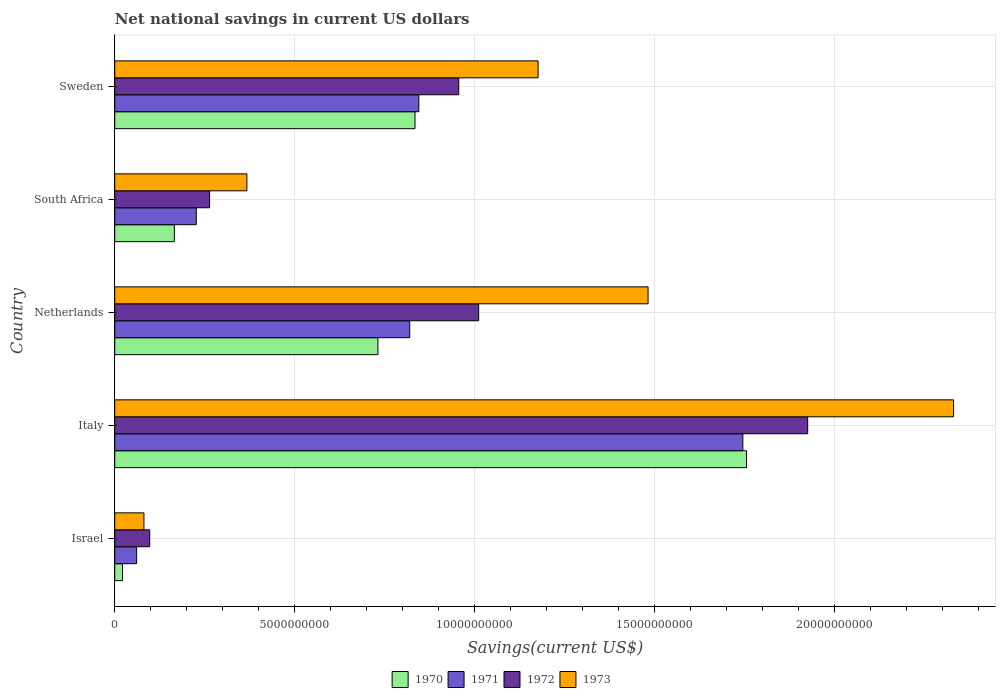What is the label of the 2nd group of bars from the top?
Your answer should be compact. South Africa. What is the net national savings in 1971 in Sweden?
Provide a succinct answer. 8.45e+09. Across all countries, what is the maximum net national savings in 1973?
Provide a succinct answer. 2.33e+1. Across all countries, what is the minimum net national savings in 1973?
Give a very brief answer. 8.11e+08. In which country was the net national savings in 1971 maximum?
Your answer should be very brief. Italy. What is the total net national savings in 1972 in the graph?
Make the answer very short. 4.25e+1. What is the difference between the net national savings in 1971 in Israel and that in Italy?
Provide a succinct answer. -1.68e+1. What is the difference between the net national savings in 1970 in Israel and the net national savings in 1971 in South Africa?
Your response must be concise. -2.05e+09. What is the average net national savings in 1970 per country?
Provide a short and direct response. 7.02e+09. What is the difference between the net national savings in 1970 and net national savings in 1973 in Italy?
Give a very brief answer. -5.75e+09. In how many countries, is the net national savings in 1971 greater than 15000000000 US$?
Your answer should be very brief. 1. What is the ratio of the net national savings in 1972 in South Africa to that in Sweden?
Give a very brief answer. 0.28. Is the net national savings in 1972 in Italy less than that in South Africa?
Provide a short and direct response. No. What is the difference between the highest and the second highest net national savings in 1970?
Your answer should be compact. 9.21e+09. What is the difference between the highest and the lowest net national savings in 1970?
Offer a very short reply. 1.73e+1. What does the 4th bar from the bottom in Israel represents?
Your response must be concise. 1973. How many countries are there in the graph?
Provide a short and direct response. 5. Are the values on the major ticks of X-axis written in scientific E-notation?
Your answer should be compact. No. Does the graph contain any zero values?
Ensure brevity in your answer.  No. Does the graph contain grids?
Ensure brevity in your answer.  Yes. How many legend labels are there?
Your answer should be compact. 4. What is the title of the graph?
Make the answer very short. Net national savings in current US dollars. Does "1963" appear as one of the legend labels in the graph?
Keep it short and to the point. No. What is the label or title of the X-axis?
Provide a succinct answer. Savings(current US$). What is the label or title of the Y-axis?
Make the answer very short. Country. What is the Savings(current US$) in 1970 in Israel?
Make the answer very short. 2.15e+08. What is the Savings(current US$) in 1971 in Israel?
Provide a short and direct response. 6.09e+08. What is the Savings(current US$) in 1972 in Israel?
Ensure brevity in your answer.  9.71e+08. What is the Savings(current US$) in 1973 in Israel?
Offer a very short reply. 8.11e+08. What is the Savings(current US$) in 1970 in Italy?
Provide a succinct answer. 1.76e+1. What is the Savings(current US$) of 1971 in Italy?
Your answer should be very brief. 1.75e+1. What is the Savings(current US$) in 1972 in Italy?
Give a very brief answer. 1.93e+1. What is the Savings(current US$) of 1973 in Italy?
Provide a short and direct response. 2.33e+1. What is the Savings(current US$) of 1970 in Netherlands?
Offer a very short reply. 7.31e+09. What is the Savings(current US$) of 1971 in Netherlands?
Your answer should be very brief. 8.20e+09. What is the Savings(current US$) of 1972 in Netherlands?
Provide a short and direct response. 1.01e+1. What is the Savings(current US$) of 1973 in Netherlands?
Your answer should be compact. 1.48e+1. What is the Savings(current US$) of 1970 in South Africa?
Provide a short and direct response. 1.66e+09. What is the Savings(current US$) of 1971 in South Africa?
Keep it short and to the point. 2.27e+09. What is the Savings(current US$) in 1972 in South Africa?
Offer a terse response. 2.64e+09. What is the Savings(current US$) of 1973 in South Africa?
Ensure brevity in your answer.  3.67e+09. What is the Savings(current US$) of 1970 in Sweden?
Your response must be concise. 8.34e+09. What is the Savings(current US$) of 1971 in Sweden?
Your answer should be very brief. 8.45e+09. What is the Savings(current US$) of 1972 in Sweden?
Make the answer very short. 9.56e+09. What is the Savings(current US$) in 1973 in Sweden?
Offer a terse response. 1.18e+1. Across all countries, what is the maximum Savings(current US$) of 1970?
Give a very brief answer. 1.76e+1. Across all countries, what is the maximum Savings(current US$) of 1971?
Ensure brevity in your answer.  1.75e+1. Across all countries, what is the maximum Savings(current US$) in 1972?
Give a very brief answer. 1.93e+1. Across all countries, what is the maximum Savings(current US$) of 1973?
Your answer should be very brief. 2.33e+1. Across all countries, what is the minimum Savings(current US$) of 1970?
Keep it short and to the point. 2.15e+08. Across all countries, what is the minimum Savings(current US$) in 1971?
Your answer should be compact. 6.09e+08. Across all countries, what is the minimum Savings(current US$) in 1972?
Keep it short and to the point. 9.71e+08. Across all countries, what is the minimum Savings(current US$) of 1973?
Offer a very short reply. 8.11e+08. What is the total Savings(current US$) of 1970 in the graph?
Ensure brevity in your answer.  3.51e+1. What is the total Savings(current US$) of 1971 in the graph?
Offer a very short reply. 3.70e+1. What is the total Savings(current US$) of 1972 in the graph?
Offer a very short reply. 4.25e+1. What is the total Savings(current US$) in 1973 in the graph?
Offer a terse response. 5.44e+1. What is the difference between the Savings(current US$) of 1970 in Israel and that in Italy?
Offer a very short reply. -1.73e+1. What is the difference between the Savings(current US$) in 1971 in Israel and that in Italy?
Offer a very short reply. -1.68e+1. What is the difference between the Savings(current US$) in 1972 in Israel and that in Italy?
Your answer should be compact. -1.83e+1. What is the difference between the Savings(current US$) in 1973 in Israel and that in Italy?
Keep it short and to the point. -2.25e+1. What is the difference between the Savings(current US$) of 1970 in Israel and that in Netherlands?
Your answer should be compact. -7.10e+09. What is the difference between the Savings(current US$) of 1971 in Israel and that in Netherlands?
Your response must be concise. -7.59e+09. What is the difference between the Savings(current US$) of 1972 in Israel and that in Netherlands?
Make the answer very short. -9.14e+09. What is the difference between the Savings(current US$) of 1973 in Israel and that in Netherlands?
Your answer should be very brief. -1.40e+1. What is the difference between the Savings(current US$) of 1970 in Israel and that in South Africa?
Your answer should be compact. -1.44e+09. What is the difference between the Savings(current US$) of 1971 in Israel and that in South Africa?
Offer a terse response. -1.66e+09. What is the difference between the Savings(current US$) of 1972 in Israel and that in South Africa?
Your response must be concise. -1.66e+09. What is the difference between the Savings(current US$) in 1973 in Israel and that in South Africa?
Ensure brevity in your answer.  -2.86e+09. What is the difference between the Savings(current US$) of 1970 in Israel and that in Sweden?
Ensure brevity in your answer.  -8.13e+09. What is the difference between the Savings(current US$) of 1971 in Israel and that in Sweden?
Provide a short and direct response. -7.84e+09. What is the difference between the Savings(current US$) in 1972 in Israel and that in Sweden?
Offer a very short reply. -8.59e+09. What is the difference between the Savings(current US$) of 1973 in Israel and that in Sweden?
Ensure brevity in your answer.  -1.10e+1. What is the difference between the Savings(current US$) of 1970 in Italy and that in Netherlands?
Give a very brief answer. 1.02e+1. What is the difference between the Savings(current US$) in 1971 in Italy and that in Netherlands?
Offer a terse response. 9.26e+09. What is the difference between the Savings(current US$) in 1972 in Italy and that in Netherlands?
Keep it short and to the point. 9.14e+09. What is the difference between the Savings(current US$) of 1973 in Italy and that in Netherlands?
Your response must be concise. 8.49e+09. What is the difference between the Savings(current US$) in 1970 in Italy and that in South Africa?
Your answer should be very brief. 1.59e+1. What is the difference between the Savings(current US$) in 1971 in Italy and that in South Africa?
Keep it short and to the point. 1.52e+1. What is the difference between the Savings(current US$) of 1972 in Italy and that in South Africa?
Provide a short and direct response. 1.66e+1. What is the difference between the Savings(current US$) of 1973 in Italy and that in South Africa?
Provide a short and direct response. 1.96e+1. What is the difference between the Savings(current US$) in 1970 in Italy and that in Sweden?
Provide a succinct answer. 9.21e+09. What is the difference between the Savings(current US$) in 1971 in Italy and that in Sweden?
Make the answer very short. 9.00e+09. What is the difference between the Savings(current US$) in 1972 in Italy and that in Sweden?
Offer a very short reply. 9.70e+09. What is the difference between the Savings(current US$) of 1973 in Italy and that in Sweden?
Provide a short and direct response. 1.15e+1. What is the difference between the Savings(current US$) in 1970 in Netherlands and that in South Africa?
Your response must be concise. 5.66e+09. What is the difference between the Savings(current US$) in 1971 in Netherlands and that in South Africa?
Provide a short and direct response. 5.93e+09. What is the difference between the Savings(current US$) of 1972 in Netherlands and that in South Africa?
Your answer should be very brief. 7.48e+09. What is the difference between the Savings(current US$) of 1973 in Netherlands and that in South Africa?
Your response must be concise. 1.11e+1. What is the difference between the Savings(current US$) of 1970 in Netherlands and that in Sweden?
Make the answer very short. -1.03e+09. What is the difference between the Savings(current US$) in 1971 in Netherlands and that in Sweden?
Make the answer very short. -2.53e+08. What is the difference between the Savings(current US$) of 1972 in Netherlands and that in Sweden?
Your answer should be very brief. 5.54e+08. What is the difference between the Savings(current US$) in 1973 in Netherlands and that in Sweden?
Offer a terse response. 3.06e+09. What is the difference between the Savings(current US$) of 1970 in South Africa and that in Sweden?
Keep it short and to the point. -6.69e+09. What is the difference between the Savings(current US$) of 1971 in South Africa and that in Sweden?
Make the answer very short. -6.18e+09. What is the difference between the Savings(current US$) in 1972 in South Africa and that in Sweden?
Provide a short and direct response. -6.92e+09. What is the difference between the Savings(current US$) of 1973 in South Africa and that in Sweden?
Offer a very short reply. -8.09e+09. What is the difference between the Savings(current US$) of 1970 in Israel and the Savings(current US$) of 1971 in Italy?
Make the answer very short. -1.72e+1. What is the difference between the Savings(current US$) of 1970 in Israel and the Savings(current US$) of 1972 in Italy?
Your answer should be compact. -1.90e+1. What is the difference between the Savings(current US$) of 1970 in Israel and the Savings(current US$) of 1973 in Italy?
Offer a terse response. -2.31e+1. What is the difference between the Savings(current US$) of 1971 in Israel and the Savings(current US$) of 1972 in Italy?
Provide a succinct answer. -1.86e+1. What is the difference between the Savings(current US$) of 1971 in Israel and the Savings(current US$) of 1973 in Italy?
Ensure brevity in your answer.  -2.27e+1. What is the difference between the Savings(current US$) of 1972 in Israel and the Savings(current US$) of 1973 in Italy?
Provide a short and direct response. -2.23e+1. What is the difference between the Savings(current US$) in 1970 in Israel and the Savings(current US$) in 1971 in Netherlands?
Give a very brief answer. -7.98e+09. What is the difference between the Savings(current US$) of 1970 in Israel and the Savings(current US$) of 1972 in Netherlands?
Ensure brevity in your answer.  -9.90e+09. What is the difference between the Savings(current US$) in 1970 in Israel and the Savings(current US$) in 1973 in Netherlands?
Your response must be concise. -1.46e+1. What is the difference between the Savings(current US$) of 1971 in Israel and the Savings(current US$) of 1972 in Netherlands?
Provide a short and direct response. -9.50e+09. What is the difference between the Savings(current US$) in 1971 in Israel and the Savings(current US$) in 1973 in Netherlands?
Offer a terse response. -1.42e+1. What is the difference between the Savings(current US$) in 1972 in Israel and the Savings(current US$) in 1973 in Netherlands?
Offer a terse response. -1.38e+1. What is the difference between the Savings(current US$) in 1970 in Israel and the Savings(current US$) in 1971 in South Africa?
Ensure brevity in your answer.  -2.05e+09. What is the difference between the Savings(current US$) of 1970 in Israel and the Savings(current US$) of 1972 in South Africa?
Offer a terse response. -2.42e+09. What is the difference between the Savings(current US$) in 1970 in Israel and the Savings(current US$) in 1973 in South Africa?
Keep it short and to the point. -3.46e+09. What is the difference between the Savings(current US$) in 1971 in Israel and the Savings(current US$) in 1972 in South Africa?
Make the answer very short. -2.03e+09. What is the difference between the Savings(current US$) in 1971 in Israel and the Savings(current US$) in 1973 in South Africa?
Offer a very short reply. -3.06e+09. What is the difference between the Savings(current US$) of 1972 in Israel and the Savings(current US$) of 1973 in South Africa?
Ensure brevity in your answer.  -2.70e+09. What is the difference between the Savings(current US$) of 1970 in Israel and the Savings(current US$) of 1971 in Sweden?
Your answer should be compact. -8.23e+09. What is the difference between the Savings(current US$) of 1970 in Israel and the Savings(current US$) of 1972 in Sweden?
Offer a very short reply. -9.34e+09. What is the difference between the Savings(current US$) of 1970 in Israel and the Savings(current US$) of 1973 in Sweden?
Give a very brief answer. -1.15e+1. What is the difference between the Savings(current US$) of 1971 in Israel and the Savings(current US$) of 1972 in Sweden?
Ensure brevity in your answer.  -8.95e+09. What is the difference between the Savings(current US$) in 1971 in Israel and the Savings(current US$) in 1973 in Sweden?
Provide a short and direct response. -1.12e+1. What is the difference between the Savings(current US$) in 1972 in Israel and the Savings(current US$) in 1973 in Sweden?
Provide a short and direct response. -1.08e+1. What is the difference between the Savings(current US$) of 1970 in Italy and the Savings(current US$) of 1971 in Netherlands?
Ensure brevity in your answer.  9.36e+09. What is the difference between the Savings(current US$) in 1970 in Italy and the Savings(current US$) in 1972 in Netherlands?
Your answer should be compact. 7.44e+09. What is the difference between the Savings(current US$) in 1970 in Italy and the Savings(current US$) in 1973 in Netherlands?
Provide a short and direct response. 2.74e+09. What is the difference between the Savings(current US$) of 1971 in Italy and the Savings(current US$) of 1972 in Netherlands?
Provide a succinct answer. 7.34e+09. What is the difference between the Savings(current US$) in 1971 in Italy and the Savings(current US$) in 1973 in Netherlands?
Your answer should be very brief. 2.63e+09. What is the difference between the Savings(current US$) in 1972 in Italy and the Savings(current US$) in 1973 in Netherlands?
Offer a very short reply. 4.44e+09. What is the difference between the Savings(current US$) in 1970 in Italy and the Savings(current US$) in 1971 in South Africa?
Offer a very short reply. 1.53e+1. What is the difference between the Savings(current US$) in 1970 in Italy and the Savings(current US$) in 1972 in South Africa?
Your answer should be very brief. 1.49e+1. What is the difference between the Savings(current US$) of 1970 in Italy and the Savings(current US$) of 1973 in South Africa?
Keep it short and to the point. 1.39e+1. What is the difference between the Savings(current US$) of 1971 in Italy and the Savings(current US$) of 1972 in South Africa?
Offer a very short reply. 1.48e+1. What is the difference between the Savings(current US$) in 1971 in Italy and the Savings(current US$) in 1973 in South Africa?
Your response must be concise. 1.38e+1. What is the difference between the Savings(current US$) in 1972 in Italy and the Savings(current US$) in 1973 in South Africa?
Your answer should be very brief. 1.56e+1. What is the difference between the Savings(current US$) in 1970 in Italy and the Savings(current US$) in 1971 in Sweden?
Keep it short and to the point. 9.11e+09. What is the difference between the Savings(current US$) of 1970 in Italy and the Savings(current US$) of 1972 in Sweden?
Provide a succinct answer. 8.00e+09. What is the difference between the Savings(current US$) of 1970 in Italy and the Savings(current US$) of 1973 in Sweden?
Your answer should be very brief. 5.79e+09. What is the difference between the Savings(current US$) in 1971 in Italy and the Savings(current US$) in 1972 in Sweden?
Your response must be concise. 7.89e+09. What is the difference between the Savings(current US$) in 1971 in Italy and the Savings(current US$) in 1973 in Sweden?
Your answer should be compact. 5.69e+09. What is the difference between the Savings(current US$) of 1972 in Italy and the Savings(current US$) of 1973 in Sweden?
Give a very brief answer. 7.49e+09. What is the difference between the Savings(current US$) in 1970 in Netherlands and the Savings(current US$) in 1971 in South Africa?
Give a very brief answer. 5.05e+09. What is the difference between the Savings(current US$) of 1970 in Netherlands and the Savings(current US$) of 1972 in South Africa?
Give a very brief answer. 4.68e+09. What is the difference between the Savings(current US$) of 1970 in Netherlands and the Savings(current US$) of 1973 in South Africa?
Ensure brevity in your answer.  3.64e+09. What is the difference between the Savings(current US$) in 1971 in Netherlands and the Savings(current US$) in 1972 in South Africa?
Your answer should be compact. 5.56e+09. What is the difference between the Savings(current US$) in 1971 in Netherlands and the Savings(current US$) in 1973 in South Africa?
Keep it short and to the point. 4.52e+09. What is the difference between the Savings(current US$) of 1972 in Netherlands and the Savings(current US$) of 1973 in South Africa?
Your response must be concise. 6.44e+09. What is the difference between the Savings(current US$) in 1970 in Netherlands and the Savings(current US$) in 1971 in Sweden?
Your response must be concise. -1.14e+09. What is the difference between the Savings(current US$) of 1970 in Netherlands and the Savings(current US$) of 1972 in Sweden?
Give a very brief answer. -2.25e+09. What is the difference between the Savings(current US$) in 1970 in Netherlands and the Savings(current US$) in 1973 in Sweden?
Keep it short and to the point. -4.45e+09. What is the difference between the Savings(current US$) of 1971 in Netherlands and the Savings(current US$) of 1972 in Sweden?
Provide a short and direct response. -1.36e+09. What is the difference between the Savings(current US$) in 1971 in Netherlands and the Savings(current US$) in 1973 in Sweden?
Provide a short and direct response. -3.57e+09. What is the difference between the Savings(current US$) in 1972 in Netherlands and the Savings(current US$) in 1973 in Sweden?
Make the answer very short. -1.65e+09. What is the difference between the Savings(current US$) in 1970 in South Africa and the Savings(current US$) in 1971 in Sweden?
Your answer should be compact. -6.79e+09. What is the difference between the Savings(current US$) of 1970 in South Africa and the Savings(current US$) of 1972 in Sweden?
Offer a terse response. -7.90e+09. What is the difference between the Savings(current US$) of 1970 in South Africa and the Savings(current US$) of 1973 in Sweden?
Make the answer very short. -1.01e+1. What is the difference between the Savings(current US$) of 1971 in South Africa and the Savings(current US$) of 1972 in Sweden?
Make the answer very short. -7.29e+09. What is the difference between the Savings(current US$) in 1971 in South Africa and the Savings(current US$) in 1973 in Sweden?
Your answer should be very brief. -9.50e+09. What is the difference between the Savings(current US$) of 1972 in South Africa and the Savings(current US$) of 1973 in Sweden?
Provide a short and direct response. -9.13e+09. What is the average Savings(current US$) in 1970 per country?
Provide a succinct answer. 7.02e+09. What is the average Savings(current US$) in 1971 per country?
Your answer should be compact. 7.39e+09. What is the average Savings(current US$) in 1972 per country?
Offer a terse response. 8.51e+09. What is the average Savings(current US$) in 1973 per country?
Your response must be concise. 1.09e+1. What is the difference between the Savings(current US$) in 1970 and Savings(current US$) in 1971 in Israel?
Ensure brevity in your answer.  -3.94e+08. What is the difference between the Savings(current US$) in 1970 and Savings(current US$) in 1972 in Israel?
Your response must be concise. -7.56e+08. What is the difference between the Savings(current US$) in 1970 and Savings(current US$) in 1973 in Israel?
Provide a succinct answer. -5.96e+08. What is the difference between the Savings(current US$) of 1971 and Savings(current US$) of 1972 in Israel?
Your answer should be compact. -3.62e+08. What is the difference between the Savings(current US$) of 1971 and Savings(current US$) of 1973 in Israel?
Give a very brief answer. -2.02e+08. What is the difference between the Savings(current US$) of 1972 and Savings(current US$) of 1973 in Israel?
Give a very brief answer. 1.60e+08. What is the difference between the Savings(current US$) of 1970 and Savings(current US$) of 1971 in Italy?
Your answer should be compact. 1.03e+08. What is the difference between the Savings(current US$) of 1970 and Savings(current US$) of 1972 in Italy?
Your answer should be compact. -1.70e+09. What is the difference between the Savings(current US$) of 1970 and Savings(current US$) of 1973 in Italy?
Your answer should be very brief. -5.75e+09. What is the difference between the Savings(current US$) in 1971 and Savings(current US$) in 1972 in Italy?
Offer a terse response. -1.80e+09. What is the difference between the Savings(current US$) in 1971 and Savings(current US$) in 1973 in Italy?
Provide a short and direct response. -5.86e+09. What is the difference between the Savings(current US$) in 1972 and Savings(current US$) in 1973 in Italy?
Offer a very short reply. -4.05e+09. What is the difference between the Savings(current US$) of 1970 and Savings(current US$) of 1971 in Netherlands?
Keep it short and to the point. -8.83e+08. What is the difference between the Savings(current US$) in 1970 and Savings(current US$) in 1972 in Netherlands?
Ensure brevity in your answer.  -2.80e+09. What is the difference between the Savings(current US$) of 1970 and Savings(current US$) of 1973 in Netherlands?
Keep it short and to the point. -7.51e+09. What is the difference between the Savings(current US$) of 1971 and Savings(current US$) of 1972 in Netherlands?
Provide a short and direct response. -1.92e+09. What is the difference between the Savings(current US$) of 1971 and Savings(current US$) of 1973 in Netherlands?
Keep it short and to the point. -6.62e+09. What is the difference between the Savings(current US$) of 1972 and Savings(current US$) of 1973 in Netherlands?
Offer a very short reply. -4.71e+09. What is the difference between the Savings(current US$) of 1970 and Savings(current US$) of 1971 in South Africa?
Ensure brevity in your answer.  -6.09e+08. What is the difference between the Savings(current US$) of 1970 and Savings(current US$) of 1972 in South Africa?
Give a very brief answer. -9.79e+08. What is the difference between the Savings(current US$) in 1970 and Savings(current US$) in 1973 in South Africa?
Your answer should be very brief. -2.02e+09. What is the difference between the Savings(current US$) of 1971 and Savings(current US$) of 1972 in South Africa?
Your answer should be very brief. -3.70e+08. What is the difference between the Savings(current US$) in 1971 and Savings(current US$) in 1973 in South Africa?
Offer a very short reply. -1.41e+09. What is the difference between the Savings(current US$) in 1972 and Savings(current US$) in 1973 in South Africa?
Offer a very short reply. -1.04e+09. What is the difference between the Savings(current US$) of 1970 and Savings(current US$) of 1971 in Sweden?
Your response must be concise. -1.07e+08. What is the difference between the Savings(current US$) in 1970 and Savings(current US$) in 1972 in Sweden?
Offer a terse response. -1.22e+09. What is the difference between the Savings(current US$) of 1970 and Savings(current US$) of 1973 in Sweden?
Your answer should be very brief. -3.42e+09. What is the difference between the Savings(current US$) of 1971 and Savings(current US$) of 1972 in Sweden?
Offer a very short reply. -1.11e+09. What is the difference between the Savings(current US$) of 1971 and Savings(current US$) of 1973 in Sweden?
Your answer should be compact. -3.31e+09. What is the difference between the Savings(current US$) of 1972 and Savings(current US$) of 1973 in Sweden?
Offer a terse response. -2.20e+09. What is the ratio of the Savings(current US$) of 1970 in Israel to that in Italy?
Your response must be concise. 0.01. What is the ratio of the Savings(current US$) of 1971 in Israel to that in Italy?
Keep it short and to the point. 0.03. What is the ratio of the Savings(current US$) in 1972 in Israel to that in Italy?
Your answer should be compact. 0.05. What is the ratio of the Savings(current US$) of 1973 in Israel to that in Italy?
Provide a short and direct response. 0.03. What is the ratio of the Savings(current US$) in 1970 in Israel to that in Netherlands?
Provide a succinct answer. 0.03. What is the ratio of the Savings(current US$) in 1971 in Israel to that in Netherlands?
Offer a terse response. 0.07. What is the ratio of the Savings(current US$) of 1972 in Israel to that in Netherlands?
Make the answer very short. 0.1. What is the ratio of the Savings(current US$) in 1973 in Israel to that in Netherlands?
Your answer should be very brief. 0.05. What is the ratio of the Savings(current US$) in 1970 in Israel to that in South Africa?
Make the answer very short. 0.13. What is the ratio of the Savings(current US$) of 1971 in Israel to that in South Africa?
Give a very brief answer. 0.27. What is the ratio of the Savings(current US$) in 1972 in Israel to that in South Africa?
Provide a succinct answer. 0.37. What is the ratio of the Savings(current US$) of 1973 in Israel to that in South Africa?
Make the answer very short. 0.22. What is the ratio of the Savings(current US$) of 1970 in Israel to that in Sweden?
Offer a terse response. 0.03. What is the ratio of the Savings(current US$) in 1971 in Israel to that in Sweden?
Make the answer very short. 0.07. What is the ratio of the Savings(current US$) in 1972 in Israel to that in Sweden?
Ensure brevity in your answer.  0.1. What is the ratio of the Savings(current US$) in 1973 in Israel to that in Sweden?
Offer a terse response. 0.07. What is the ratio of the Savings(current US$) in 1970 in Italy to that in Netherlands?
Make the answer very short. 2.4. What is the ratio of the Savings(current US$) of 1971 in Italy to that in Netherlands?
Give a very brief answer. 2.13. What is the ratio of the Savings(current US$) of 1972 in Italy to that in Netherlands?
Make the answer very short. 1.9. What is the ratio of the Savings(current US$) in 1973 in Italy to that in Netherlands?
Provide a short and direct response. 1.57. What is the ratio of the Savings(current US$) in 1970 in Italy to that in South Africa?
Your response must be concise. 10.6. What is the ratio of the Savings(current US$) in 1971 in Italy to that in South Africa?
Ensure brevity in your answer.  7.7. What is the ratio of the Savings(current US$) of 1972 in Italy to that in South Africa?
Offer a very short reply. 7.31. What is the ratio of the Savings(current US$) in 1973 in Italy to that in South Africa?
Offer a terse response. 6.35. What is the ratio of the Savings(current US$) of 1970 in Italy to that in Sweden?
Ensure brevity in your answer.  2.1. What is the ratio of the Savings(current US$) of 1971 in Italy to that in Sweden?
Your answer should be compact. 2.07. What is the ratio of the Savings(current US$) in 1972 in Italy to that in Sweden?
Your answer should be very brief. 2.01. What is the ratio of the Savings(current US$) of 1973 in Italy to that in Sweden?
Your response must be concise. 1.98. What is the ratio of the Savings(current US$) of 1970 in Netherlands to that in South Africa?
Offer a very short reply. 4.42. What is the ratio of the Savings(current US$) of 1971 in Netherlands to that in South Africa?
Make the answer very short. 3.62. What is the ratio of the Savings(current US$) in 1972 in Netherlands to that in South Africa?
Your answer should be compact. 3.84. What is the ratio of the Savings(current US$) of 1973 in Netherlands to that in South Africa?
Offer a terse response. 4.04. What is the ratio of the Savings(current US$) in 1970 in Netherlands to that in Sweden?
Give a very brief answer. 0.88. What is the ratio of the Savings(current US$) in 1972 in Netherlands to that in Sweden?
Your answer should be very brief. 1.06. What is the ratio of the Savings(current US$) of 1973 in Netherlands to that in Sweden?
Offer a terse response. 1.26. What is the ratio of the Savings(current US$) of 1970 in South Africa to that in Sweden?
Your answer should be very brief. 0.2. What is the ratio of the Savings(current US$) of 1971 in South Africa to that in Sweden?
Provide a succinct answer. 0.27. What is the ratio of the Savings(current US$) in 1972 in South Africa to that in Sweden?
Ensure brevity in your answer.  0.28. What is the ratio of the Savings(current US$) in 1973 in South Africa to that in Sweden?
Your answer should be compact. 0.31. What is the difference between the highest and the second highest Savings(current US$) of 1970?
Provide a short and direct response. 9.21e+09. What is the difference between the highest and the second highest Savings(current US$) of 1971?
Offer a very short reply. 9.00e+09. What is the difference between the highest and the second highest Savings(current US$) in 1972?
Offer a very short reply. 9.14e+09. What is the difference between the highest and the second highest Savings(current US$) in 1973?
Offer a very short reply. 8.49e+09. What is the difference between the highest and the lowest Savings(current US$) in 1970?
Provide a short and direct response. 1.73e+1. What is the difference between the highest and the lowest Savings(current US$) of 1971?
Provide a succinct answer. 1.68e+1. What is the difference between the highest and the lowest Savings(current US$) in 1972?
Offer a very short reply. 1.83e+1. What is the difference between the highest and the lowest Savings(current US$) in 1973?
Provide a short and direct response. 2.25e+1. 